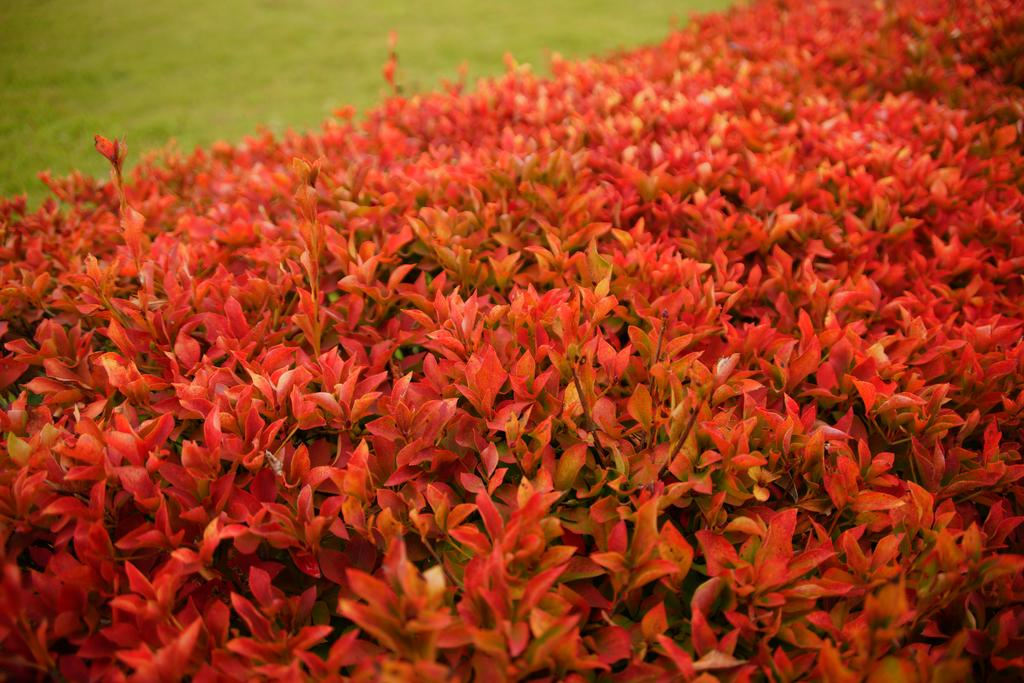What type of outdoor space is shown in the image? There is a garden in the image. What is the color of the vegetation in the garden? The garden has green vegetation. Are there any flowers in the garden? Yes, there are red flowers in the garden. What else can be seen in the image besides the garden? There are trees visible in the image. What is the color of the leaves on the trees? The leaves of the trees have a red color. How much paste is needed to print the image? The image is a photograph and does not require paste or printing. 